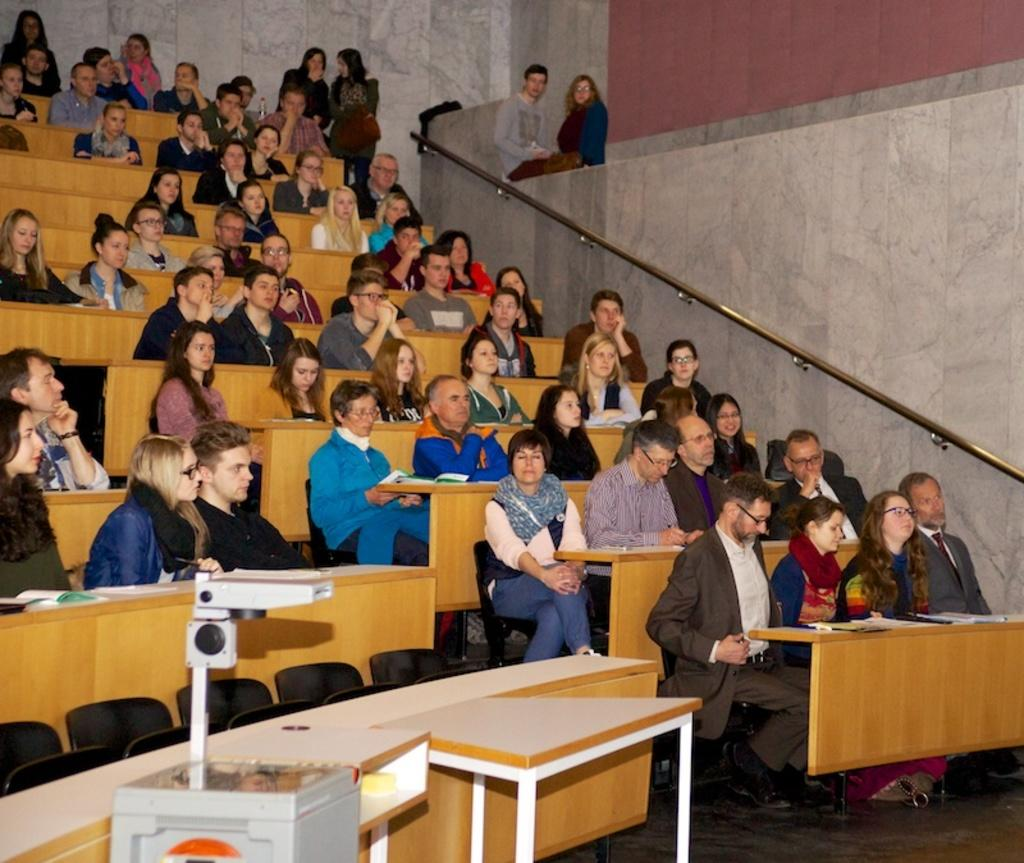What type of setting is depicted in the image? The image is of an indoor room. What are the people in the room doing? The people are sitting on chairs in the room. What objects are in front of the chairs? There are tables in front of the chairs. What items can be seen on the tables? There are books on the tables. What device is present in the room for displaying visuals? There is a projector in the room. What is the opinion of the pen on the table in the image? There is no pen present in the image, so it is not possible to determine its opinion. 